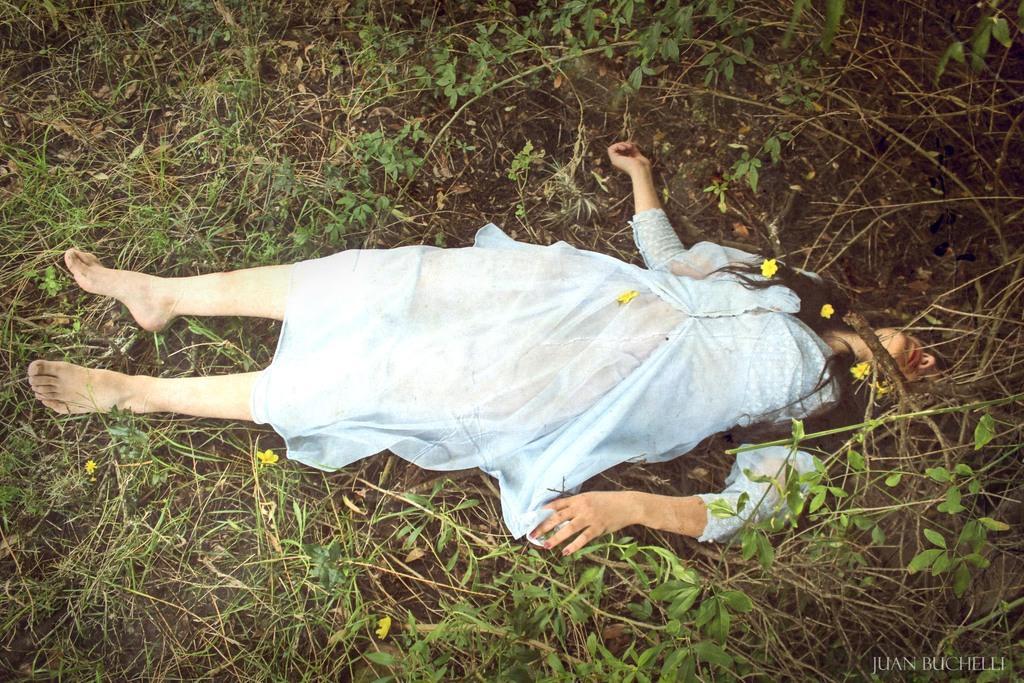How would you summarize this image in a sentence or two? In this picture we can see a woman lying on the ground with mud, flowers and plants around her. 